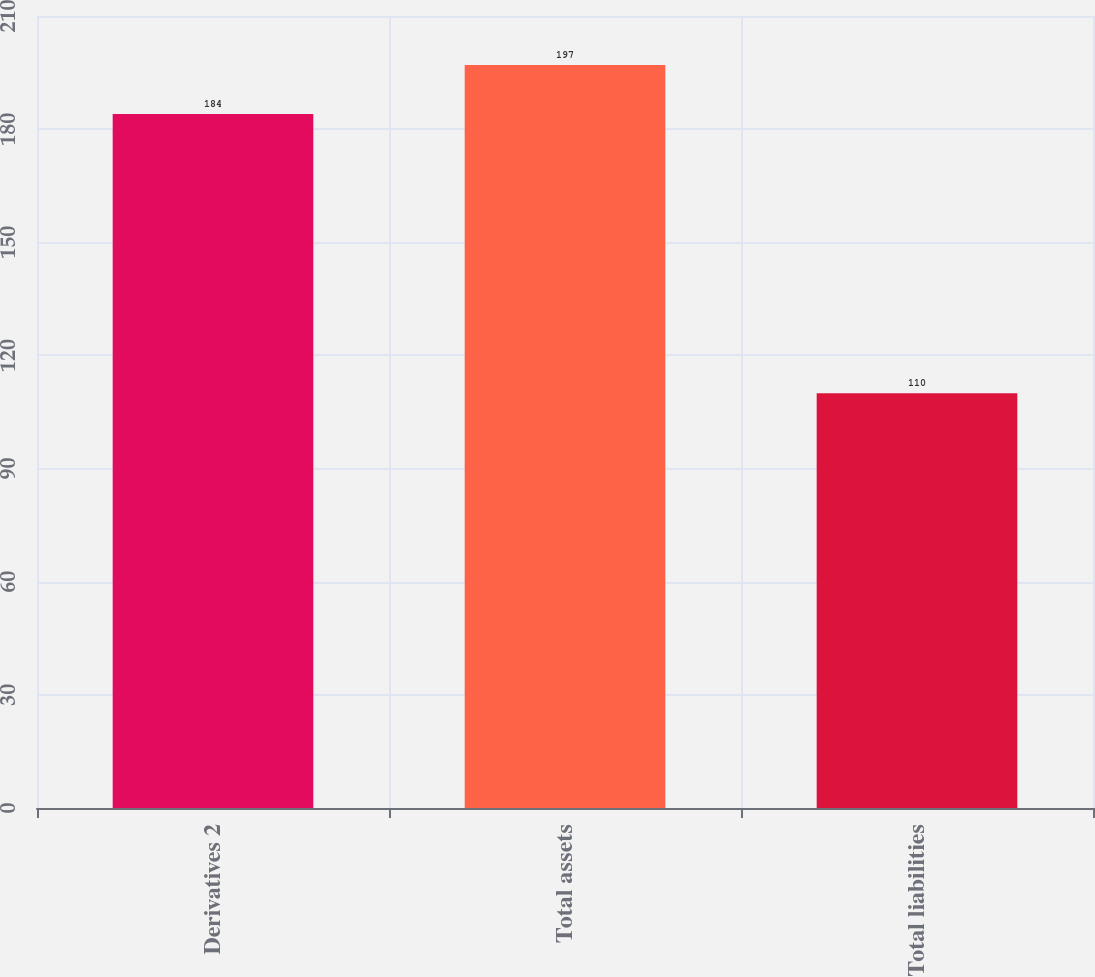Convert chart. <chart><loc_0><loc_0><loc_500><loc_500><bar_chart><fcel>Derivatives 2<fcel>Total assets<fcel>Total liabilities<nl><fcel>184<fcel>197<fcel>110<nl></chart> 